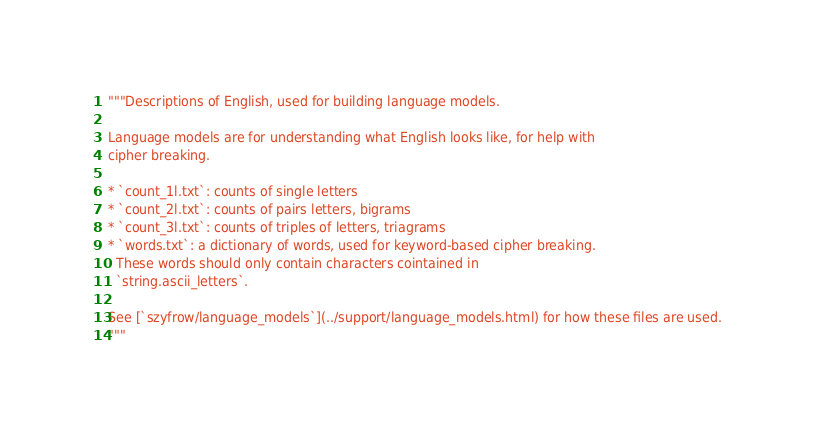Convert code to text. <code><loc_0><loc_0><loc_500><loc_500><_Python_>"""Descriptions of English, used for building language models. 

Language models are for understanding what English looks like, for help with 
cipher breaking.

* `count_1l.txt`: counts of single letters
* `count_2l.txt`: counts of pairs letters, bigrams
* `count_3l.txt`: counts of triples of letters, triagrams
* `words.txt`: a dictionary of words, used for keyword-based cipher breaking.
  These words should only contain characters cointained in 
  `string.ascii_letters`.

See [`szyfrow/language_models`](../support/language_models.html) for how these files are used.
"""</code> 